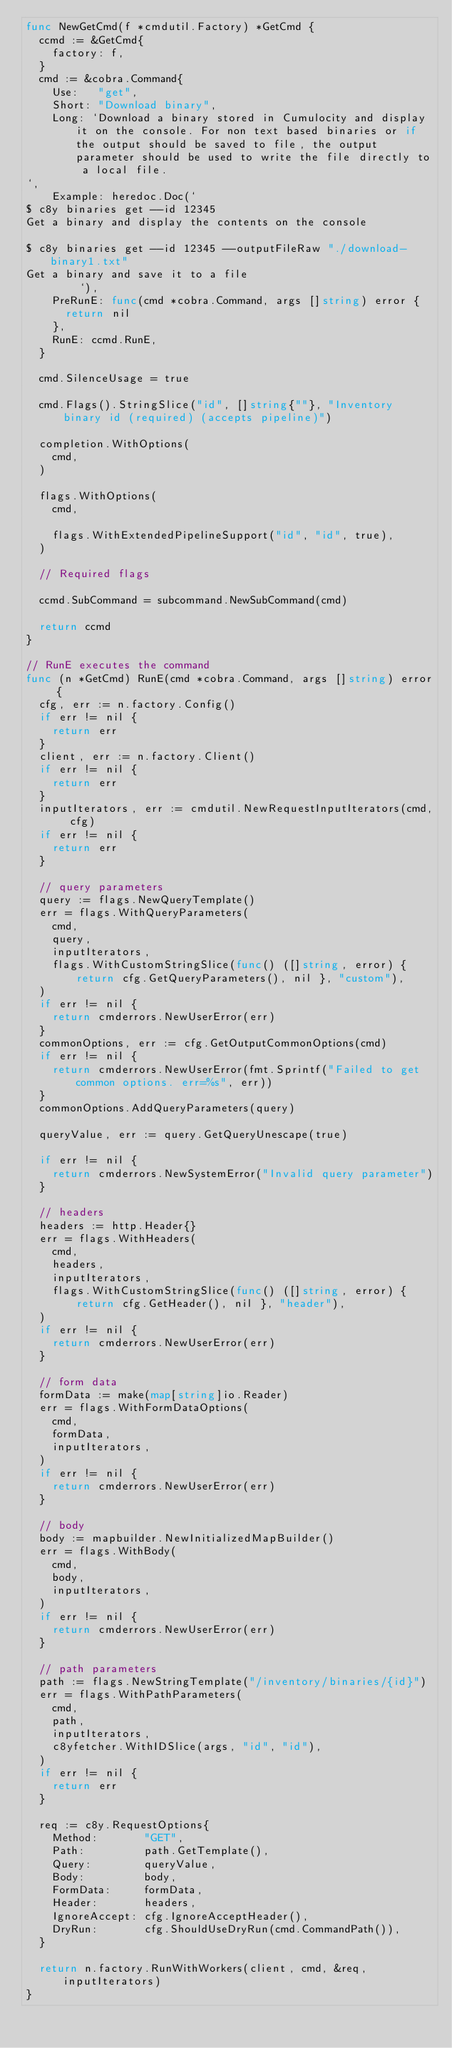<code> <loc_0><loc_0><loc_500><loc_500><_Go_>func NewGetCmd(f *cmdutil.Factory) *GetCmd {
	ccmd := &GetCmd{
		factory: f,
	}
	cmd := &cobra.Command{
		Use:   "get",
		Short: "Download binary",
		Long: `Download a binary stored in Cumulocity and display it on the console. For non text based binaries or if the output should be saved to file, the output parameter should be used to write the file directly to a local file.
`,
		Example: heredoc.Doc(`
$ c8y binaries get --id 12345
Get a binary and display the contents on the console

$ c8y binaries get --id 12345 --outputFileRaw "./download-binary1.txt"
Get a binary and save it to a file
        `),
		PreRunE: func(cmd *cobra.Command, args []string) error {
			return nil
		},
		RunE: ccmd.RunE,
	}

	cmd.SilenceUsage = true

	cmd.Flags().StringSlice("id", []string{""}, "Inventory binary id (required) (accepts pipeline)")

	completion.WithOptions(
		cmd,
	)

	flags.WithOptions(
		cmd,

		flags.WithExtendedPipelineSupport("id", "id", true),
	)

	// Required flags

	ccmd.SubCommand = subcommand.NewSubCommand(cmd)

	return ccmd
}

// RunE executes the command
func (n *GetCmd) RunE(cmd *cobra.Command, args []string) error {
	cfg, err := n.factory.Config()
	if err != nil {
		return err
	}
	client, err := n.factory.Client()
	if err != nil {
		return err
	}
	inputIterators, err := cmdutil.NewRequestInputIterators(cmd, cfg)
	if err != nil {
		return err
	}

	// query parameters
	query := flags.NewQueryTemplate()
	err = flags.WithQueryParameters(
		cmd,
		query,
		inputIterators,
		flags.WithCustomStringSlice(func() ([]string, error) { return cfg.GetQueryParameters(), nil }, "custom"),
	)
	if err != nil {
		return cmderrors.NewUserError(err)
	}
	commonOptions, err := cfg.GetOutputCommonOptions(cmd)
	if err != nil {
		return cmderrors.NewUserError(fmt.Sprintf("Failed to get common options. err=%s", err))
	}
	commonOptions.AddQueryParameters(query)

	queryValue, err := query.GetQueryUnescape(true)

	if err != nil {
		return cmderrors.NewSystemError("Invalid query parameter")
	}

	// headers
	headers := http.Header{}
	err = flags.WithHeaders(
		cmd,
		headers,
		inputIterators,
		flags.WithCustomStringSlice(func() ([]string, error) { return cfg.GetHeader(), nil }, "header"),
	)
	if err != nil {
		return cmderrors.NewUserError(err)
	}

	// form data
	formData := make(map[string]io.Reader)
	err = flags.WithFormDataOptions(
		cmd,
		formData,
		inputIterators,
	)
	if err != nil {
		return cmderrors.NewUserError(err)
	}

	// body
	body := mapbuilder.NewInitializedMapBuilder()
	err = flags.WithBody(
		cmd,
		body,
		inputIterators,
	)
	if err != nil {
		return cmderrors.NewUserError(err)
	}

	// path parameters
	path := flags.NewStringTemplate("/inventory/binaries/{id}")
	err = flags.WithPathParameters(
		cmd,
		path,
		inputIterators,
		c8yfetcher.WithIDSlice(args, "id", "id"),
	)
	if err != nil {
		return err
	}

	req := c8y.RequestOptions{
		Method:       "GET",
		Path:         path.GetTemplate(),
		Query:        queryValue,
		Body:         body,
		FormData:     formData,
		Header:       headers,
		IgnoreAccept: cfg.IgnoreAcceptHeader(),
		DryRun:       cfg.ShouldUseDryRun(cmd.CommandPath()),
	}

	return n.factory.RunWithWorkers(client, cmd, &req, inputIterators)
}
</code> 